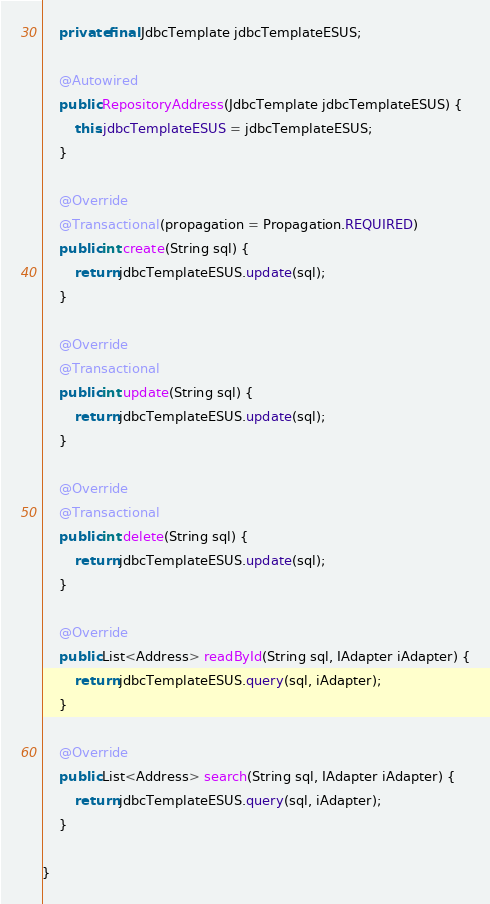Convert code to text. <code><loc_0><loc_0><loc_500><loc_500><_Java_>	private final JdbcTemplate jdbcTemplateESUS;
	
	@Autowired
	public RepositoryAddress(JdbcTemplate jdbcTemplateESUS) {
		this.jdbcTemplateESUS = jdbcTemplateESUS;
	}

	@Override
	@Transactional(propagation = Propagation.REQUIRED) 
	public int create(String sql) {
		return jdbcTemplateESUS.update(sql);
	}

	@Override
	@Transactional 
	public int update(String sql) {
		return jdbcTemplateESUS.update(sql);
	}

	@Override
	@Transactional 
	public int delete(String sql) {
		return jdbcTemplateESUS.update(sql);
	}

	@Override
	public List<Address> readById(String sql, IAdapter iAdapter) {
		return jdbcTemplateESUS.query(sql, iAdapter);
	}

	@Override
	public List<Address> search(String sql, IAdapter iAdapter) {
		return jdbcTemplateESUS.query(sql, iAdapter);
	}

}
</code> 